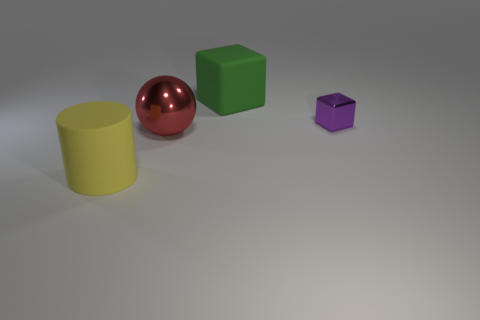Add 3 rubber objects. How many objects exist? 7 Subtract all cylinders. How many objects are left? 3 Subtract 0 gray cylinders. How many objects are left? 4 Subtract all gray cylinders. Subtract all gray blocks. How many cylinders are left? 1 Subtract all large cyan cylinders. Subtract all large metal objects. How many objects are left? 3 Add 3 purple metal things. How many purple metal things are left? 4 Add 3 large yellow cylinders. How many large yellow cylinders exist? 4 